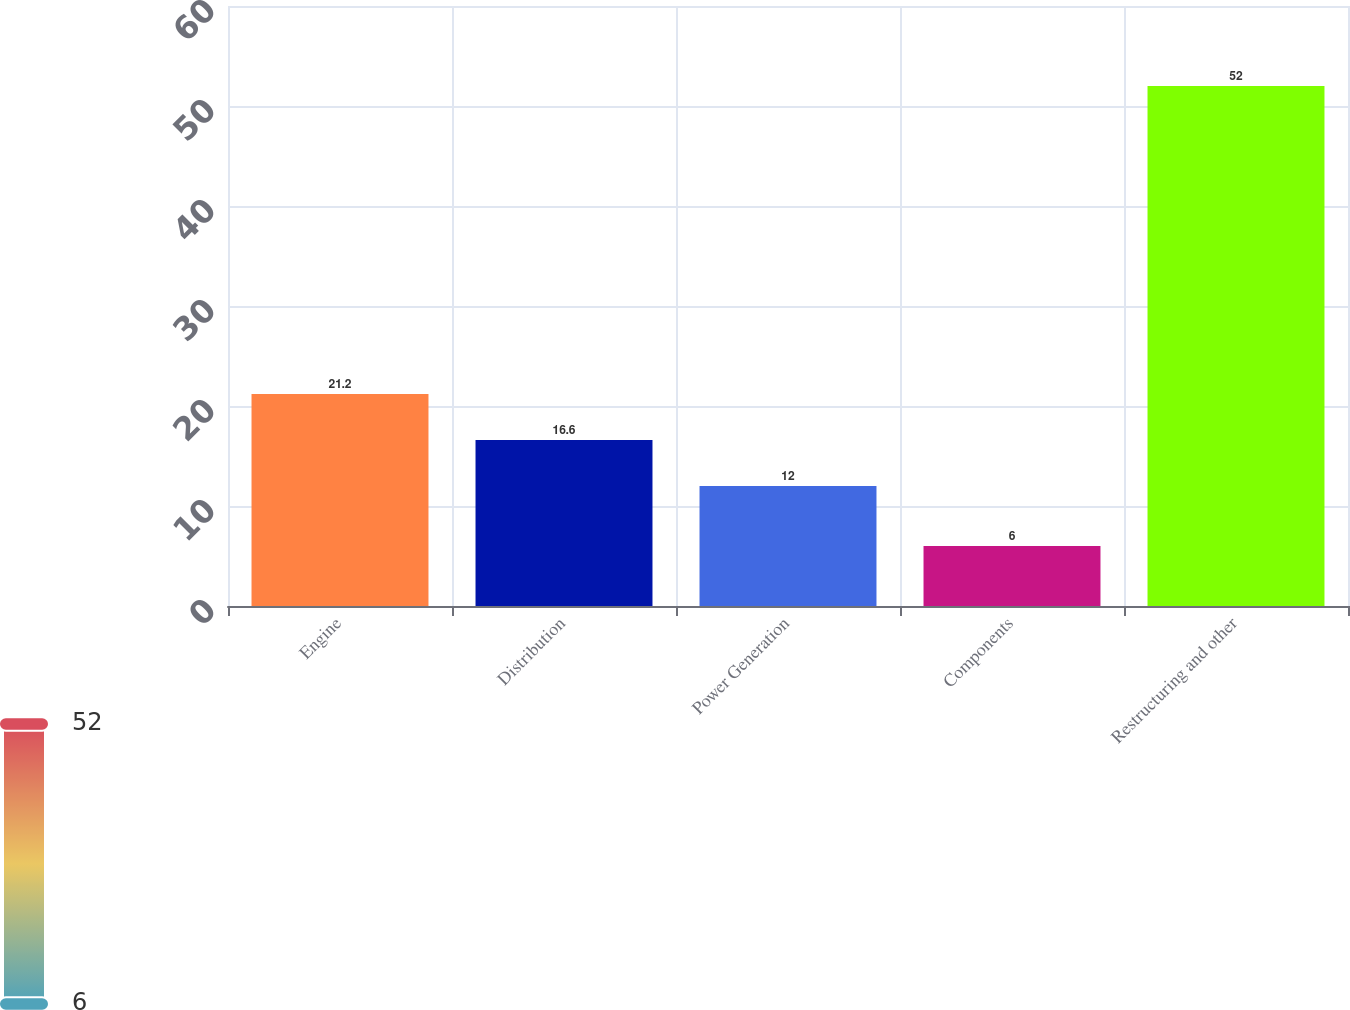Convert chart to OTSL. <chart><loc_0><loc_0><loc_500><loc_500><bar_chart><fcel>Engine<fcel>Distribution<fcel>Power Generation<fcel>Components<fcel>Restructuring and other<nl><fcel>21.2<fcel>16.6<fcel>12<fcel>6<fcel>52<nl></chart> 